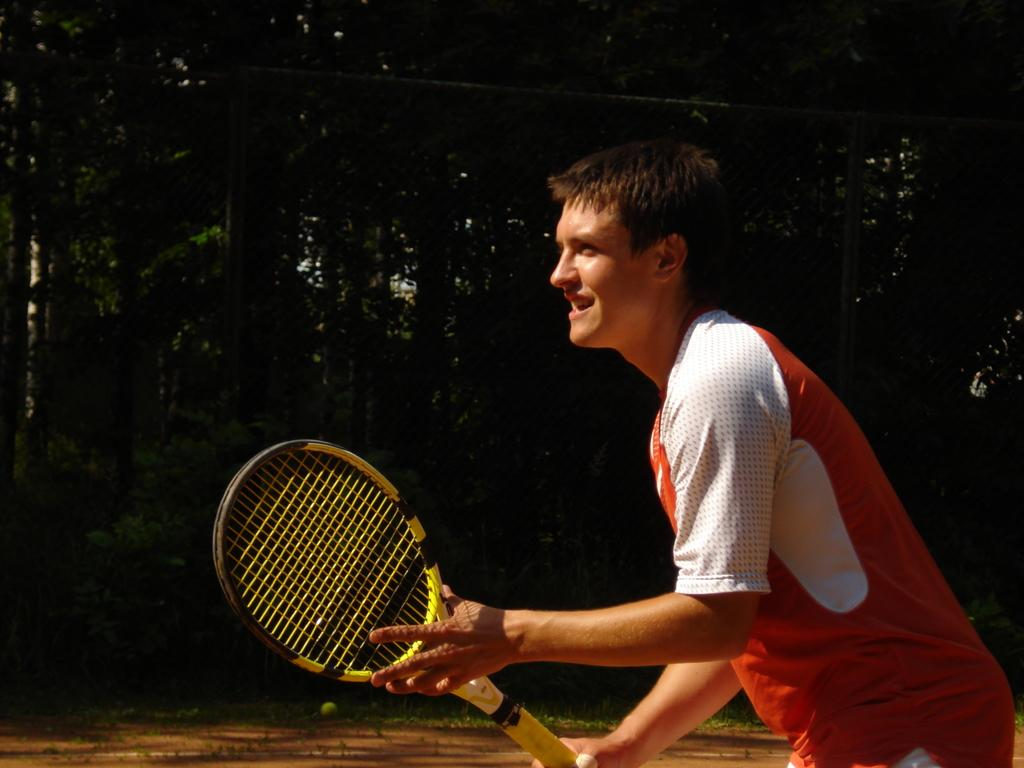Who or what is present in the image? There is a person in the image. What is the person holding in the image? The person is holding a racket. What can be seen in the background of the image? There is a group of trees visible in the background of the image. What type of celery is the person eating in the image? There is no celery present in the image, and the person is not eating anything. 